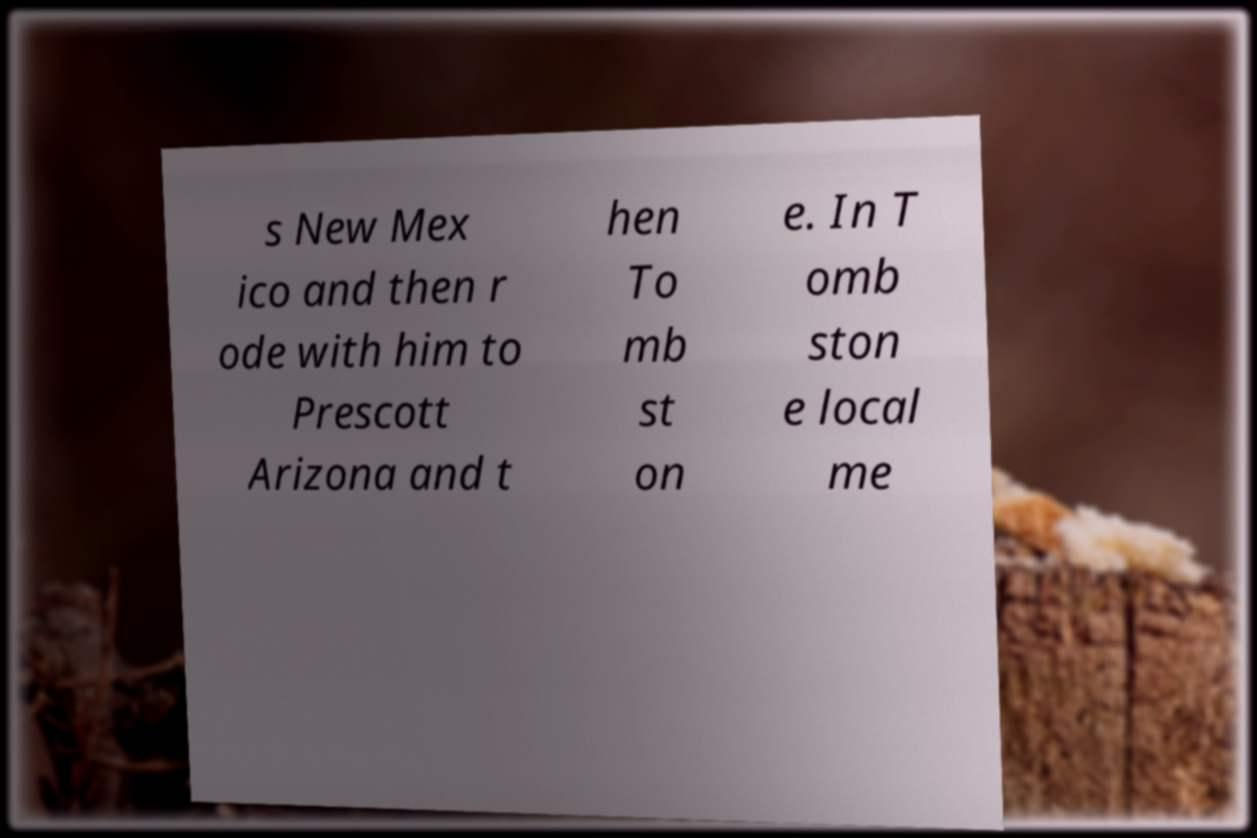There's text embedded in this image that I need extracted. Can you transcribe it verbatim? s New Mex ico and then r ode with him to Prescott Arizona and t hen To mb st on e. In T omb ston e local me 